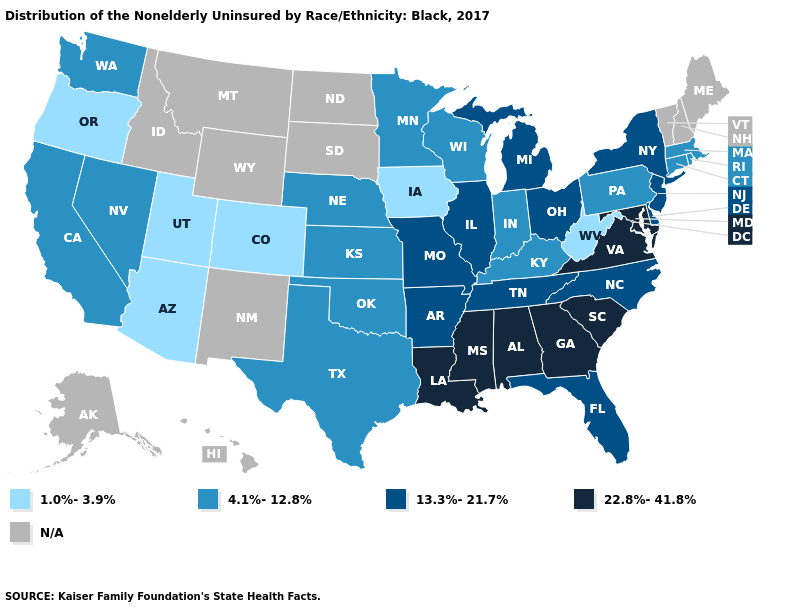Does West Virginia have the lowest value in the South?
Be succinct. Yes. Name the states that have a value in the range 4.1%-12.8%?
Give a very brief answer. California, Connecticut, Indiana, Kansas, Kentucky, Massachusetts, Minnesota, Nebraska, Nevada, Oklahoma, Pennsylvania, Rhode Island, Texas, Washington, Wisconsin. Which states have the lowest value in the West?
Quick response, please. Arizona, Colorado, Oregon, Utah. What is the value of Wisconsin?
Answer briefly. 4.1%-12.8%. Does Nevada have the lowest value in the West?
Concise answer only. No. Which states have the highest value in the USA?
Quick response, please. Alabama, Georgia, Louisiana, Maryland, Mississippi, South Carolina, Virginia. What is the highest value in the South ?
Be succinct. 22.8%-41.8%. Is the legend a continuous bar?
Quick response, please. No. What is the value of Louisiana?
Keep it brief. 22.8%-41.8%. Name the states that have a value in the range N/A?
Give a very brief answer. Alaska, Hawaii, Idaho, Maine, Montana, New Hampshire, New Mexico, North Dakota, South Dakota, Vermont, Wyoming. Which states have the lowest value in the USA?
Quick response, please. Arizona, Colorado, Iowa, Oregon, Utah, West Virginia. Name the states that have a value in the range 22.8%-41.8%?
Be succinct. Alabama, Georgia, Louisiana, Maryland, Mississippi, South Carolina, Virginia. What is the value of South Carolina?
Short answer required. 22.8%-41.8%. Which states have the lowest value in the USA?
Be succinct. Arizona, Colorado, Iowa, Oregon, Utah, West Virginia. 